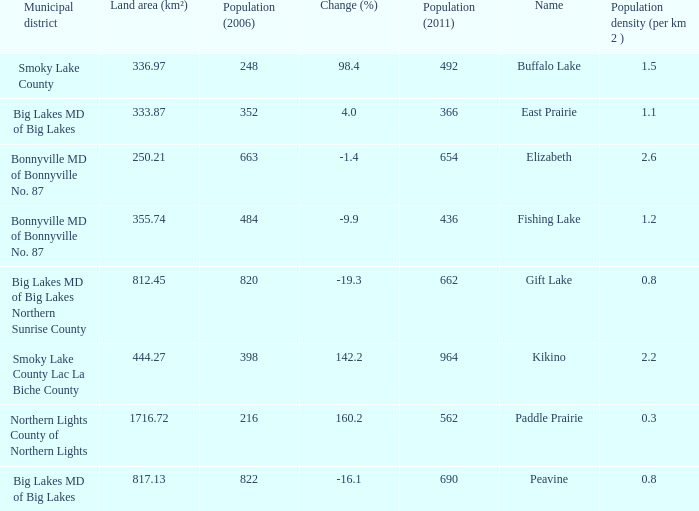What place is there a change of -19.3? 1.0. 